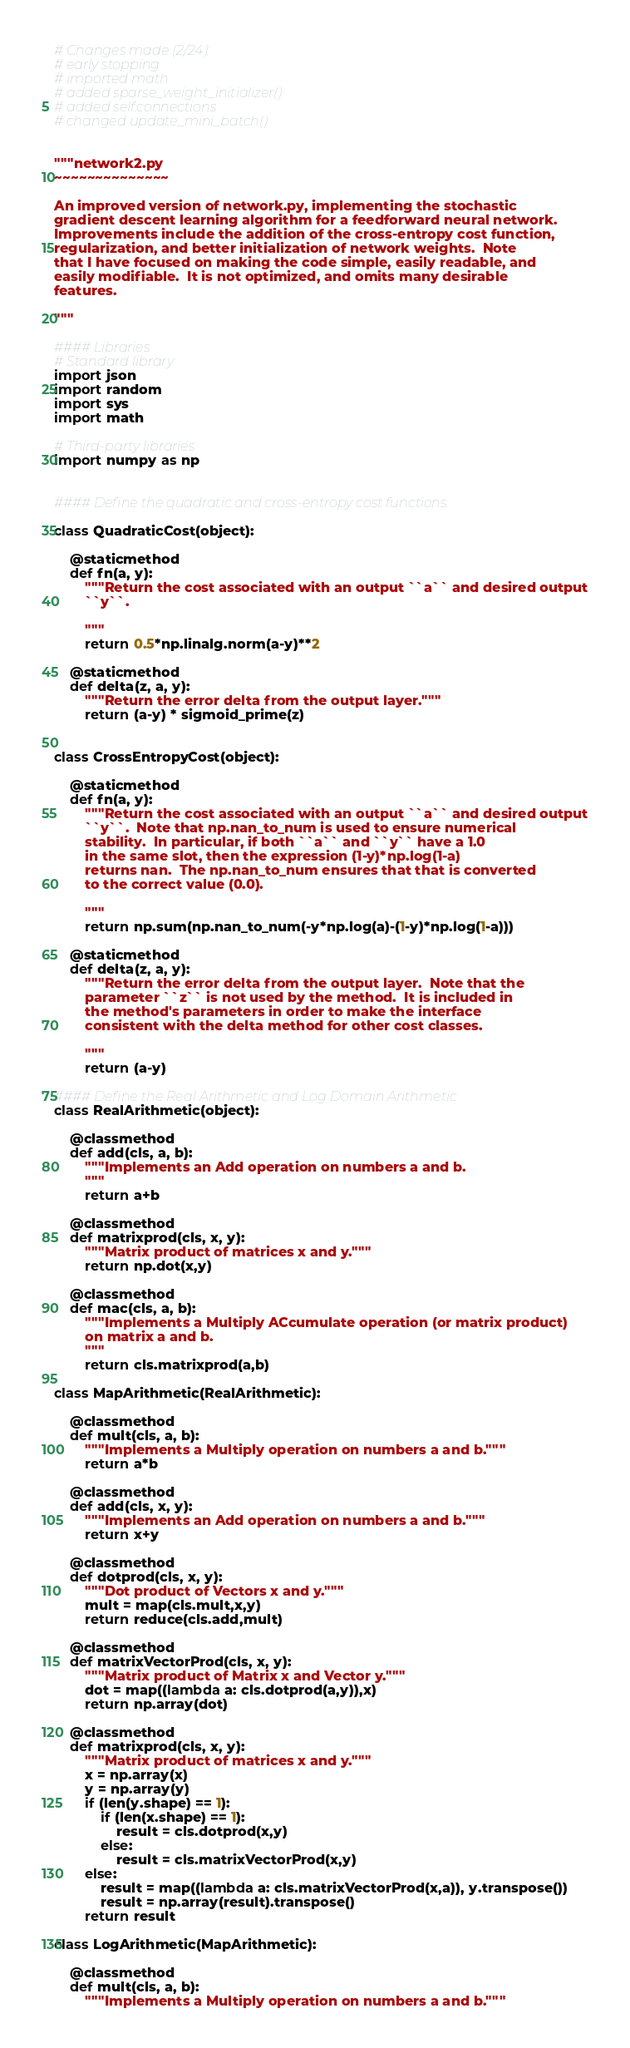<code> <loc_0><loc_0><loc_500><loc_500><_Python_># Changes made (2/24):
# early stopping
# imported math
# added sparse_weight_initializer()
# added self.connections
# changed update_mini_batch()


"""network2.py
~~~~~~~~~~~~~~

An improved version of network.py, implementing the stochastic
gradient descent learning algorithm for a feedforward neural network.
Improvements include the addition of the cross-entropy cost function,
regularization, and better initialization of network weights.  Note
that I have focused on making the code simple, easily readable, and
easily modifiable.  It is not optimized, and omits many desirable
features.

"""

#### Libraries
# Standard library
import json
import random
import sys
import math

# Third-party libraries
import numpy as np


#### Define the quadratic and cross-entropy cost functions

class QuadraticCost(object):

    @staticmethod
    def fn(a, y):
        """Return the cost associated with an output ``a`` and desired output
        ``y``.

        """
        return 0.5*np.linalg.norm(a-y)**2

    @staticmethod
    def delta(z, a, y):
        """Return the error delta from the output layer."""
        return (a-y) * sigmoid_prime(z)


class CrossEntropyCost(object):

    @staticmethod
    def fn(a, y):
        """Return the cost associated with an output ``a`` and desired output
        ``y``.  Note that np.nan_to_num is used to ensure numerical
        stability.  In particular, if both ``a`` and ``y`` have a 1.0
        in the same slot, then the expression (1-y)*np.log(1-a)
        returns nan.  The np.nan_to_num ensures that that is converted
        to the correct value (0.0).

        """
        return np.sum(np.nan_to_num(-y*np.log(a)-(1-y)*np.log(1-a)))

    @staticmethod
    def delta(z, a, y):
        """Return the error delta from the output layer.  Note that the
        parameter ``z`` is not used by the method.  It is included in
        the method's parameters in order to make the interface
        consistent with the delta method for other cost classes.

        """
        return (a-y)

#### Define the Real Arithmetic and Log Domain Arithmetic
class RealArithmetic(object):

    @classmethod
    def add(cls, a, b):
        """Implements an Add operation on numbers a and b.
        """
        return a+b

    @classmethod
    def matrixprod(cls, x, y):
        """Matrix product of matrices x and y."""
        return np.dot(x,y)

    @classmethod
    def mac(cls, a, b):
        """Implements a Multiply ACcumulate operation (or matrix product)
        on matrix a and b.
        """
        return cls.matrixprod(a,b)

class MapArithmetic(RealArithmetic):

    @classmethod
    def mult(cls, a, b):
        """Implements a Multiply operation on numbers a and b."""
        return a*b

    @classmethod
    def add(cls, x, y):
        """Implements an Add operation on numbers a and b."""
        return x+y

    @classmethod
    def dotprod(cls, x, y):
        """Dot product of Vectors x and y."""
        mult = map(cls.mult,x,y)
        return reduce(cls.add,mult)

    @classmethod
    def matrixVectorProd(cls, x, y):
        """Matrix product of Matrix x and Vector y."""
        dot = map((lambda a: cls.dotprod(a,y)),x)
        return np.array(dot)

    @classmethod
    def matrixprod(cls, x, y):
        """Matrix product of matrices x and y."""
        x = np.array(x)
        y = np.array(y)
        if (len(y.shape) == 1):
            if (len(x.shape) == 1):
                result = cls.dotprod(x,y)
            else:
                result = cls.matrixVectorProd(x,y)
        else:
            result = map((lambda a: cls.matrixVectorProd(x,a)), y.transpose())
            result = np.array(result).transpose()
        return result

class LogArithmetic(MapArithmetic):

    @classmethod
    def mult(cls, a, b):
        """Implements a Multiply operation on numbers a and b."""</code> 